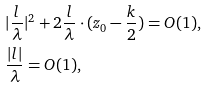<formula> <loc_0><loc_0><loc_500><loc_500>& | \frac { l } { \lambda } | ^ { 2 } + 2 \frac { l } { \lambda } \cdot ( z _ { 0 } - \frac { k } { 2 } ) = O ( 1 ) , \\ & \frac { | l | } { \lambda } = O ( 1 ) ,</formula> 